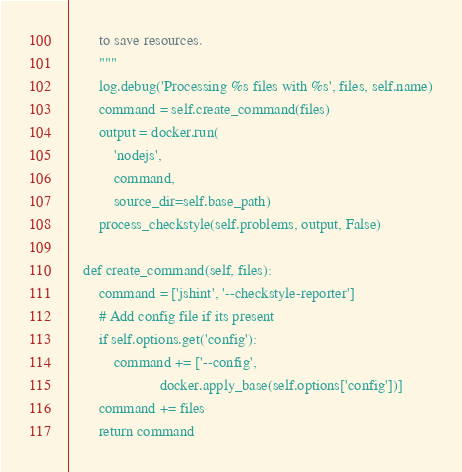<code> <loc_0><loc_0><loc_500><loc_500><_Python_>        to save resources.
        """
        log.debug('Processing %s files with %s', files, self.name)
        command = self.create_command(files)
        output = docker.run(
            'nodejs',
            command,
            source_dir=self.base_path)
        process_checkstyle(self.problems, output, False)

    def create_command(self, files):
        command = ['jshint', '--checkstyle-reporter']
        # Add config file if its present
        if self.options.get('config'):
            command += ['--config',
                        docker.apply_base(self.options['config'])]
        command += files
        return command
</code> 